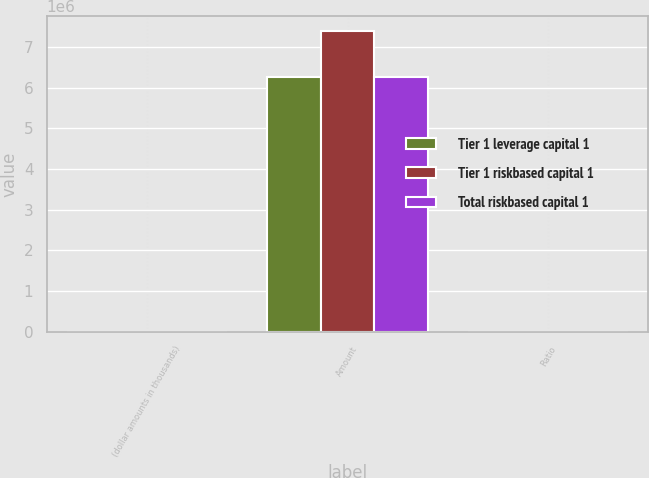Convert chart to OTSL. <chart><loc_0><loc_0><loc_500><loc_500><stacked_bar_chart><ecel><fcel>(dollar amounts in thousands)<fcel>Amount<fcel>Ratio<nl><fcel>Tier 1 leverage capital 1<fcel>2014<fcel>6.2659e+06<fcel>11.5<nl><fcel>Tier 1 riskbased capital 1<fcel>2014<fcel>7.38834e+06<fcel>13.56<nl><fcel>Total riskbased capital 1<fcel>2014<fcel>6.2659e+06<fcel>9.74<nl></chart> 